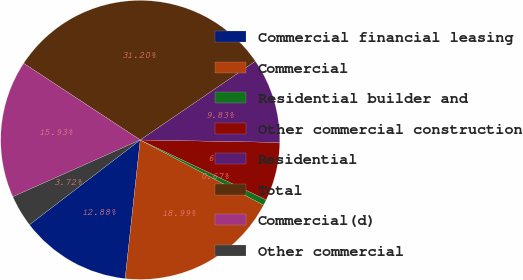Convert chart to OTSL. <chart><loc_0><loc_0><loc_500><loc_500><pie_chart><fcel>Commercial financial leasing<fcel>Commercial<fcel>Residential builder and<fcel>Other commercial construction<fcel>Residential<fcel>Total<fcel>Commercial(d)<fcel>Other commercial<nl><fcel>12.88%<fcel>18.99%<fcel>0.67%<fcel>6.78%<fcel>9.83%<fcel>31.2%<fcel>15.93%<fcel>3.72%<nl></chart> 